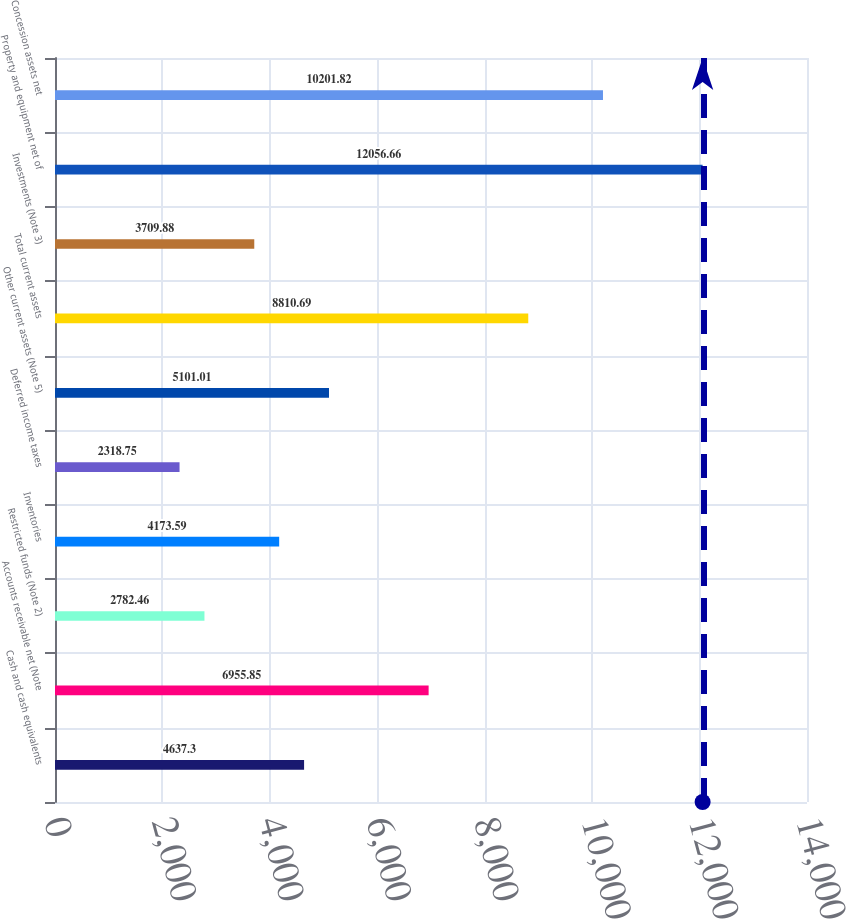Convert chart to OTSL. <chart><loc_0><loc_0><loc_500><loc_500><bar_chart><fcel>Cash and cash equivalents<fcel>Accounts receivable net (Note<fcel>Restricted funds (Note 2)<fcel>Inventories<fcel>Deferred income taxes<fcel>Other current assets (Note 5)<fcel>Total current assets<fcel>Investments (Note 3)<fcel>Property and equipment net of<fcel>Concession assets net<nl><fcel>4637.3<fcel>6955.85<fcel>2782.46<fcel>4173.59<fcel>2318.75<fcel>5101.01<fcel>8810.69<fcel>3709.88<fcel>12056.7<fcel>10201.8<nl></chart> 